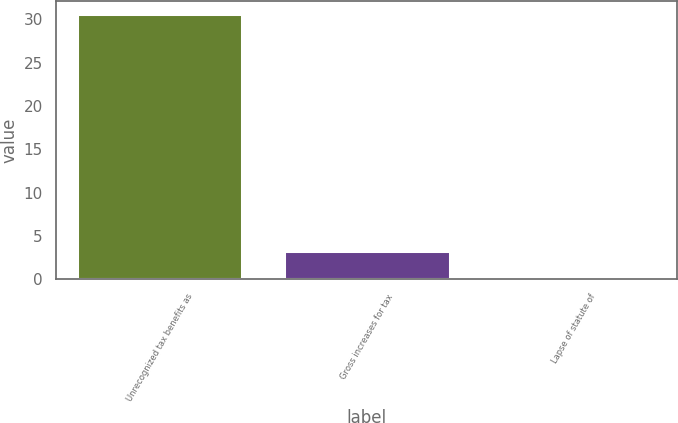Convert chart. <chart><loc_0><loc_0><loc_500><loc_500><bar_chart><fcel>Unrecognized tax benefits as<fcel>Gross increases for tax<fcel>Lapse of statute of<nl><fcel>30.65<fcel>3.25<fcel>0.3<nl></chart> 